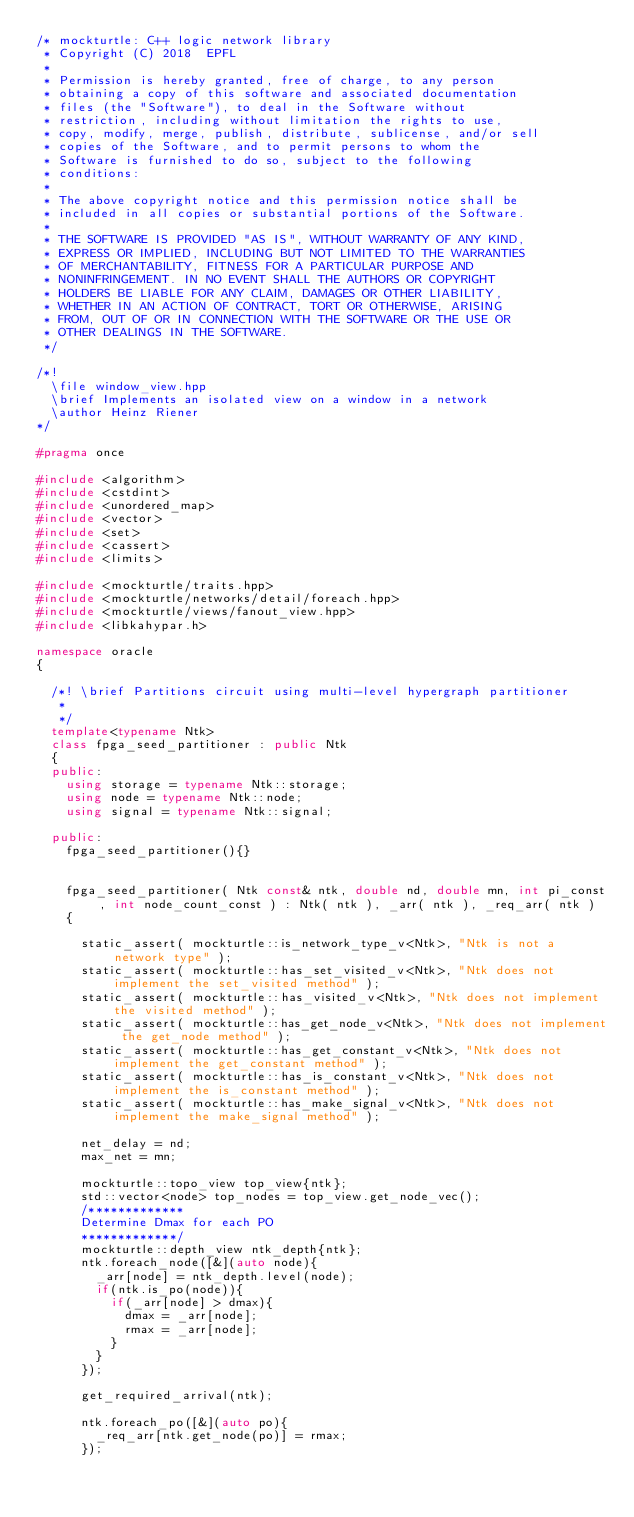<code> <loc_0><loc_0><loc_500><loc_500><_C++_>/* mockturtle: C++ logic network library
 * Copyright (C) 2018  EPFL
 *
 * Permission is hereby granted, free of charge, to any person
 * obtaining a copy of this software and associated documentation
 * files (the "Software"), to deal in the Software without
 * restriction, including without limitation the rights to use,
 * copy, modify, merge, publish, distribute, sublicense, and/or sell
 * copies of the Software, and to permit persons to whom the
 * Software is furnished to do so, subject to the following
 * conditions:
 *
 * The above copyright notice and this permission notice shall be
 * included in all copies or substantial portions of the Software.
 *
 * THE SOFTWARE IS PROVIDED "AS IS", WITHOUT WARRANTY OF ANY KIND,
 * EXPRESS OR IMPLIED, INCLUDING BUT NOT LIMITED TO THE WARRANTIES
 * OF MERCHANTABILITY, FITNESS FOR A PARTICULAR PURPOSE AND
 * NONINFRINGEMENT. IN NO EVENT SHALL THE AUTHORS OR COPYRIGHT
 * HOLDERS BE LIABLE FOR ANY CLAIM, DAMAGES OR OTHER LIABILITY,
 * WHETHER IN AN ACTION OF CONTRACT, TORT OR OTHERWISE, ARISING
 * FROM, OUT OF OR IN CONNECTION WITH THE SOFTWARE OR THE USE OR
 * OTHER DEALINGS IN THE SOFTWARE.
 */

/*!
  \file window_view.hpp
  \brief Implements an isolated view on a window in a network
  \author Heinz Riener
*/

#pragma once

#include <algorithm>
#include <cstdint>
#include <unordered_map>
#include <vector>
#include <set>
#include <cassert>
#include <limits>

#include <mockturtle/traits.hpp>
#include <mockturtle/networks/detail/foreach.hpp>
#include <mockturtle/views/fanout_view.hpp>
#include <libkahypar.h>

namespace oracle
{

  /*! \brief Partitions circuit using multi-level hypergraph partitioner
   *
   */
  template<typename Ntk>
  class fpga_seed_partitioner : public Ntk
  {
  public:
    using storage = typename Ntk::storage;
    using node = typename Ntk::node;
    using signal = typename Ntk::signal;

  public:
    fpga_seed_partitioner(){}


    fpga_seed_partitioner( Ntk const& ntk, double nd, double mn, int pi_const, int node_count_const ) : Ntk( ntk ), _arr( ntk ), _req_arr( ntk )
    {

      static_assert( mockturtle::is_network_type_v<Ntk>, "Ntk is not a network type" );
      static_assert( mockturtle::has_set_visited_v<Ntk>, "Ntk does not implement the set_visited method" );
      static_assert( mockturtle::has_visited_v<Ntk>, "Ntk does not implement the visited method" );
      static_assert( mockturtle::has_get_node_v<Ntk>, "Ntk does not implement the get_node method" );
      static_assert( mockturtle::has_get_constant_v<Ntk>, "Ntk does not implement the get_constant method" );
      static_assert( mockturtle::has_is_constant_v<Ntk>, "Ntk does not implement the is_constant method" );
      static_assert( mockturtle::has_make_signal_v<Ntk>, "Ntk does not implement the make_signal method" );

      net_delay = nd;
      max_net = mn;

      mockturtle::topo_view top_view{ntk};
      std::vector<node> top_nodes = top_view.get_node_vec();
      /*************
      Determine Dmax for each PO
      *************/
      mockturtle::depth_view ntk_depth{ntk};
      ntk.foreach_node([&](auto node){
        _arr[node] = ntk_depth.level(node);
        if(ntk.is_po(node)){
          if(_arr[node] > dmax){
            dmax = _arr[node];
            rmax = _arr[node];
          } 
        }
      });

      get_required_arrival(ntk);

      ntk.foreach_po([&](auto po){
        _req_arr[ntk.get_node(po)] = rmax;
      });</code> 